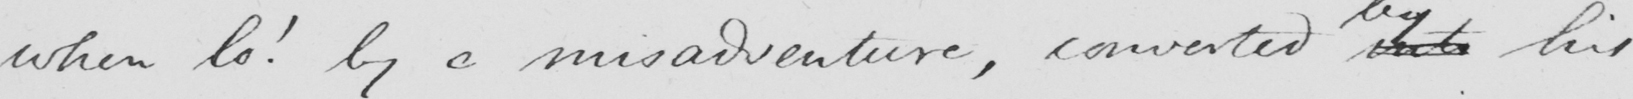Please transcribe the handwritten text in this image. when lo !  by a misadventure , converted into his 